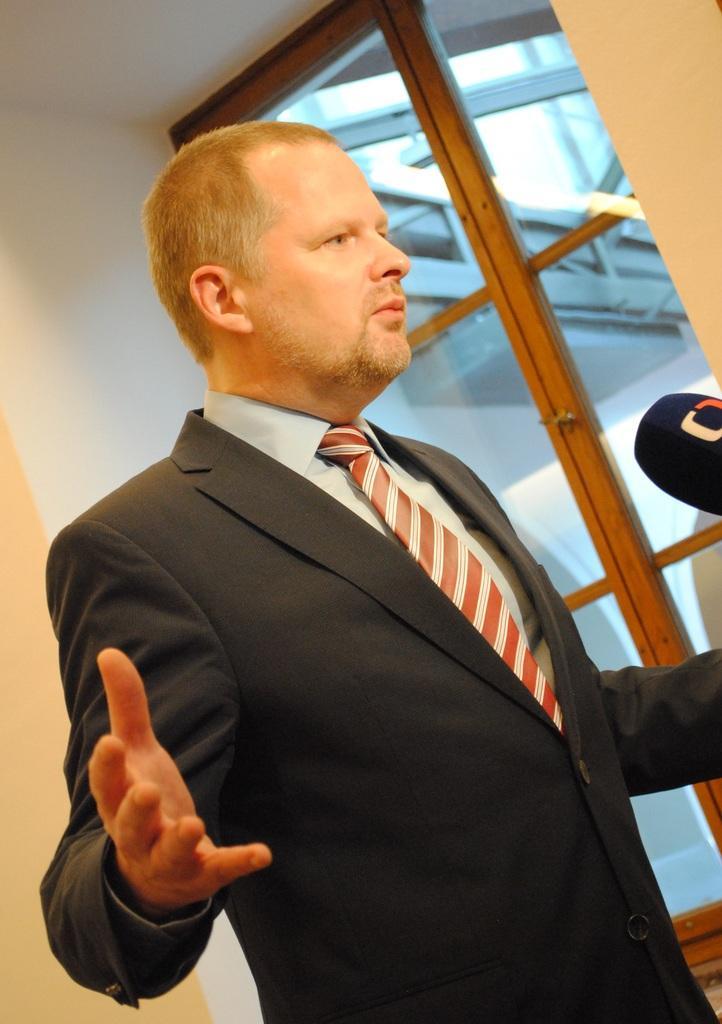Please provide a concise description of this image. In this picture there is a man who is wearing suit. In front of him I can see the mic. On the right there is a door. On the left I can see the wall. 